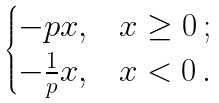<formula> <loc_0><loc_0><loc_500><loc_500>\begin{cases} - p x , & x \geq 0 \, ; \\ - \frac { 1 } { p } x , & x < 0 \, . \end{cases}</formula> 